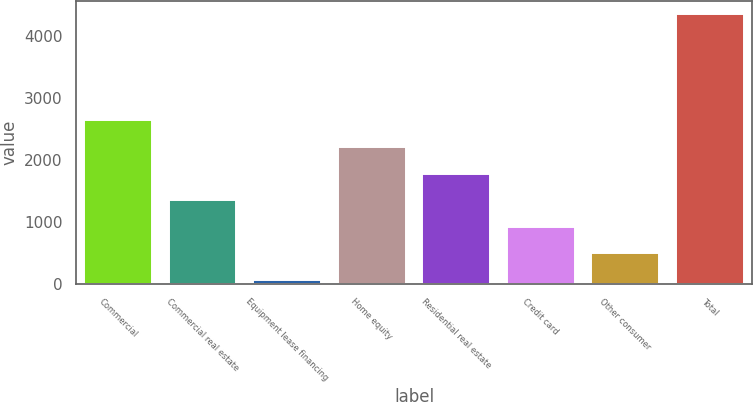<chart> <loc_0><loc_0><loc_500><loc_500><bar_chart><fcel>Commercial<fcel>Commercial real estate<fcel>Equipment lease financing<fcel>Home equity<fcel>Residential real estate<fcel>Credit card<fcel>Other consumer<fcel>Total<nl><fcel>2633<fcel>1347.5<fcel>62<fcel>2204.5<fcel>1776<fcel>919<fcel>490.5<fcel>4347<nl></chart> 